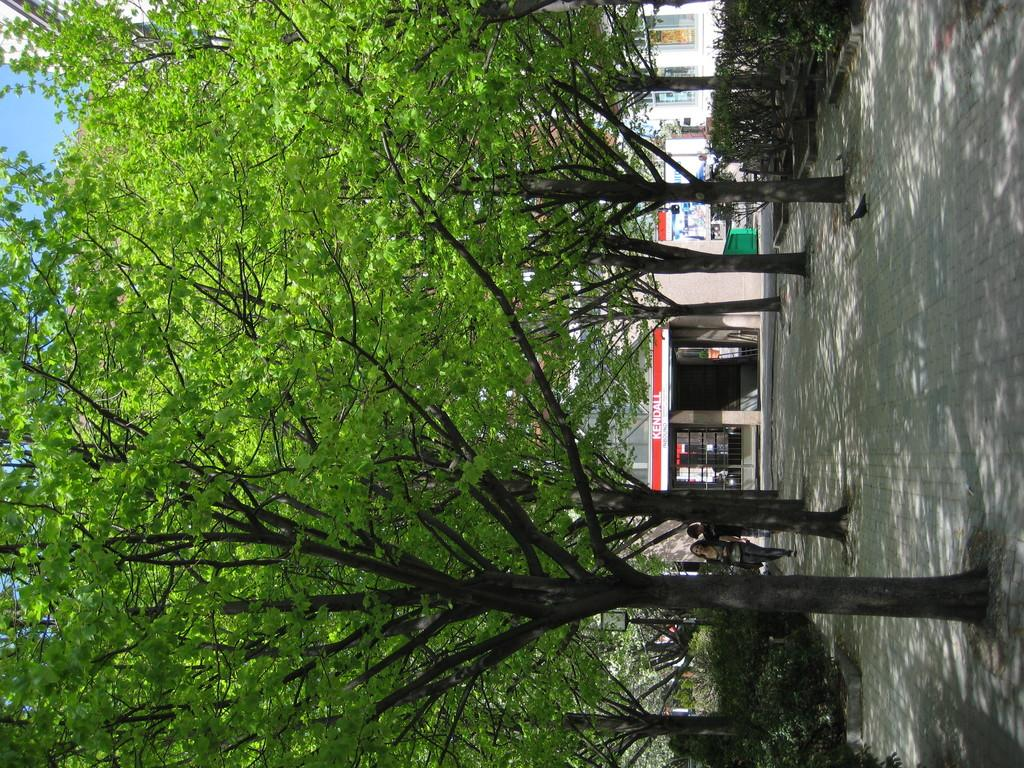What type of vegetation can be seen in the image? There are trees in the image. What type of structure is present in the image? There is a building in the image. What are the people in the image doing? The people in the image are walking on a path. What type of produce is being harvested in the image? There is no produce being harvested in the image; it features trees, a building, and people walking on a path. Where is the train station located in the image? There is no train station present in the image. 